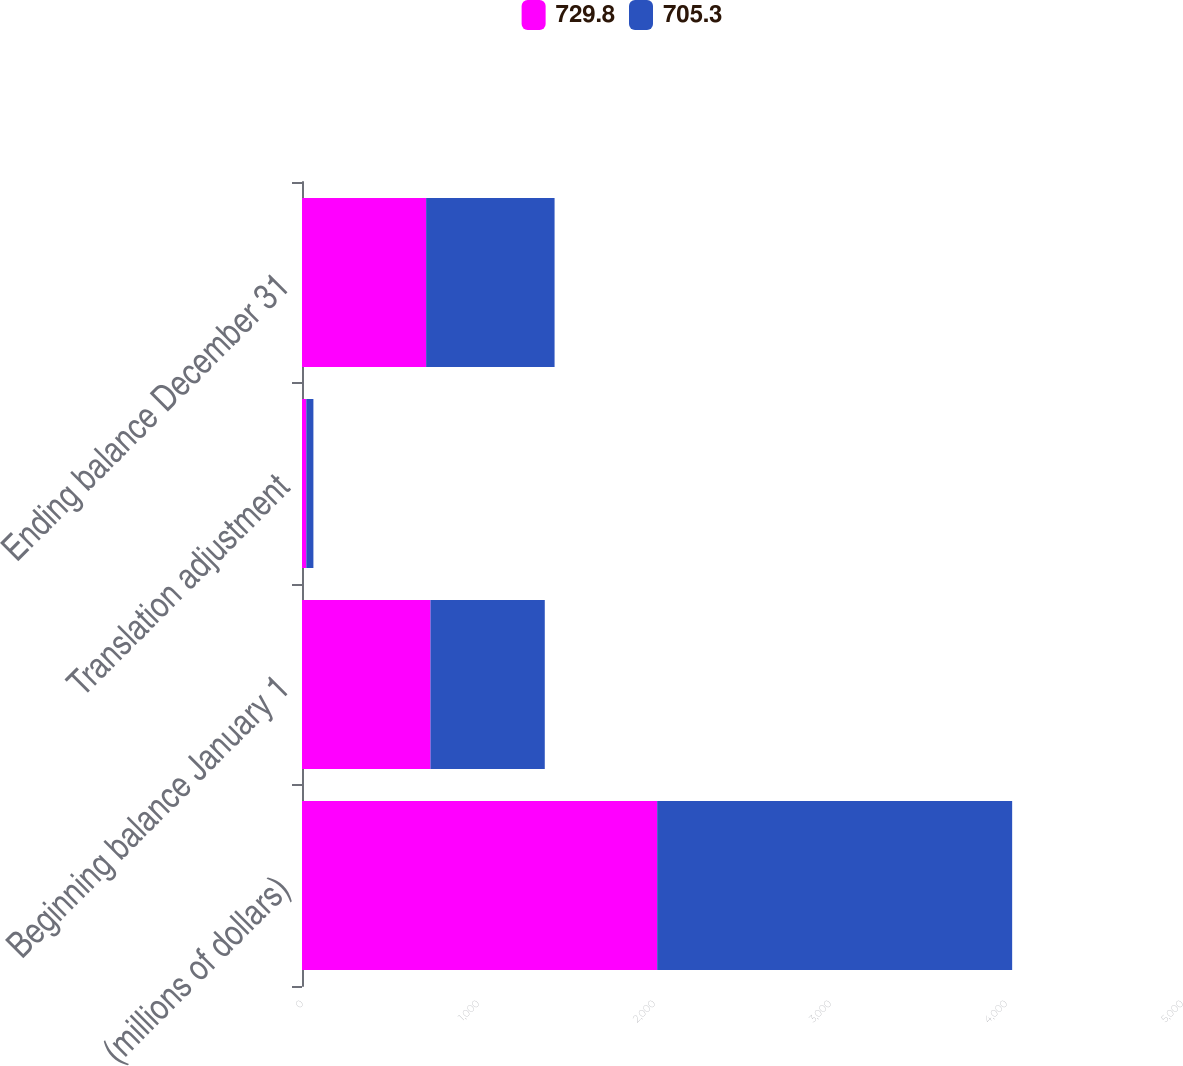Convert chart to OTSL. <chart><loc_0><loc_0><loc_500><loc_500><stacked_bar_chart><ecel><fcel>(millions of dollars)<fcel>Beginning balance January 1<fcel>Translation adjustment<fcel>Ending balance December 31<nl><fcel>729.8<fcel>2018<fcel>729.8<fcel>24.5<fcel>705.3<nl><fcel>705.3<fcel>2017<fcel>649.6<fcel>40.3<fcel>729.8<nl></chart> 